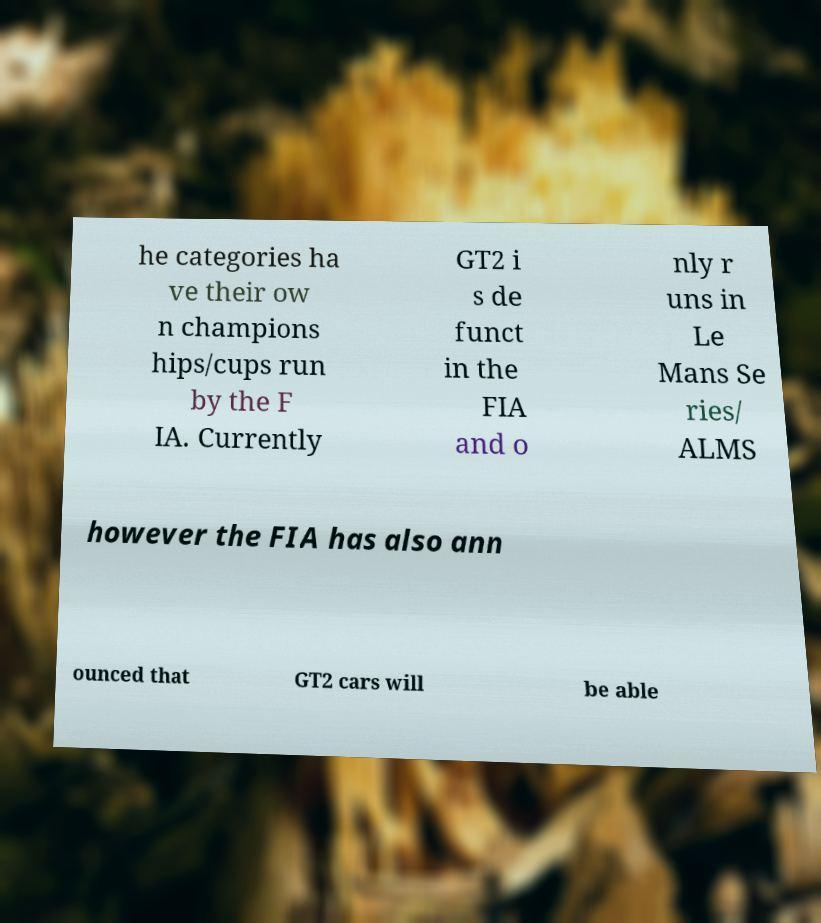Please read and relay the text visible in this image. What does it say? he categories ha ve their ow n champions hips/cups run by the F IA. Currently GT2 i s de funct in the FIA and o nly r uns in Le Mans Se ries/ ALMS however the FIA has also ann ounced that GT2 cars will be able 